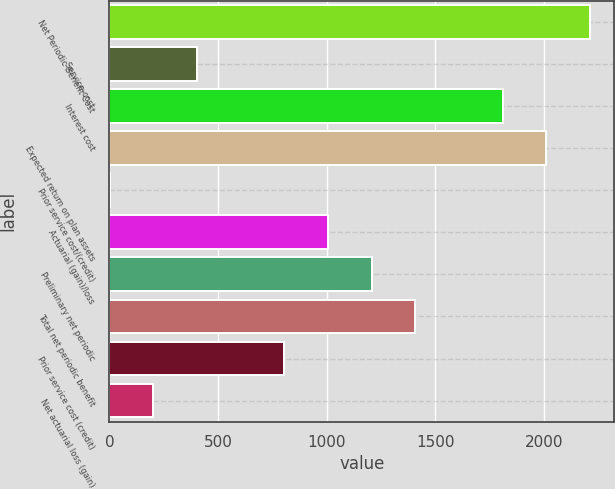<chart> <loc_0><loc_0><loc_500><loc_500><bar_chart><fcel>Net Periodic Benefit Cost<fcel>Service cost<fcel>Interest cost<fcel>Expected return on plan assets<fcel>Prior service cost/(credit)<fcel>Actuarial (gain)/loss<fcel>Preliminary net periodic<fcel>Total net periodic benefit<fcel>Prior service cost (credit)<fcel>Net actuarial loss (gain)<nl><fcel>2214.17<fcel>403.64<fcel>1811.83<fcel>2013<fcel>1.3<fcel>1007.15<fcel>1208.32<fcel>1409.49<fcel>805.98<fcel>202.47<nl></chart> 